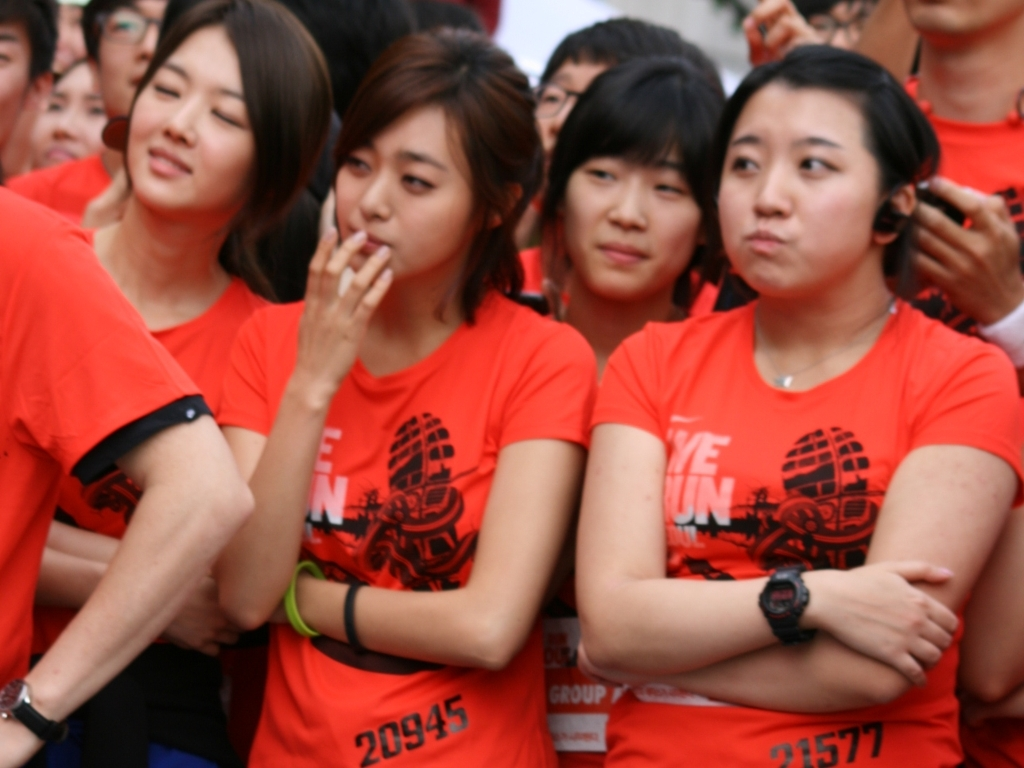Can you describe the atmosphere or mood conveyed by the people in the image? The image seems to capture a social event, possibly a public gathering or a run, indicated by the matching red shirts with numbers which might suggest participation in a group activity like a marathon. The expressions vary slightly, but there is a sense of anticipation or attention directed towards something out of frame, likely a stage or speaker. The atmosphere appears to be communal and lively, with most participants waiting expectantly. 